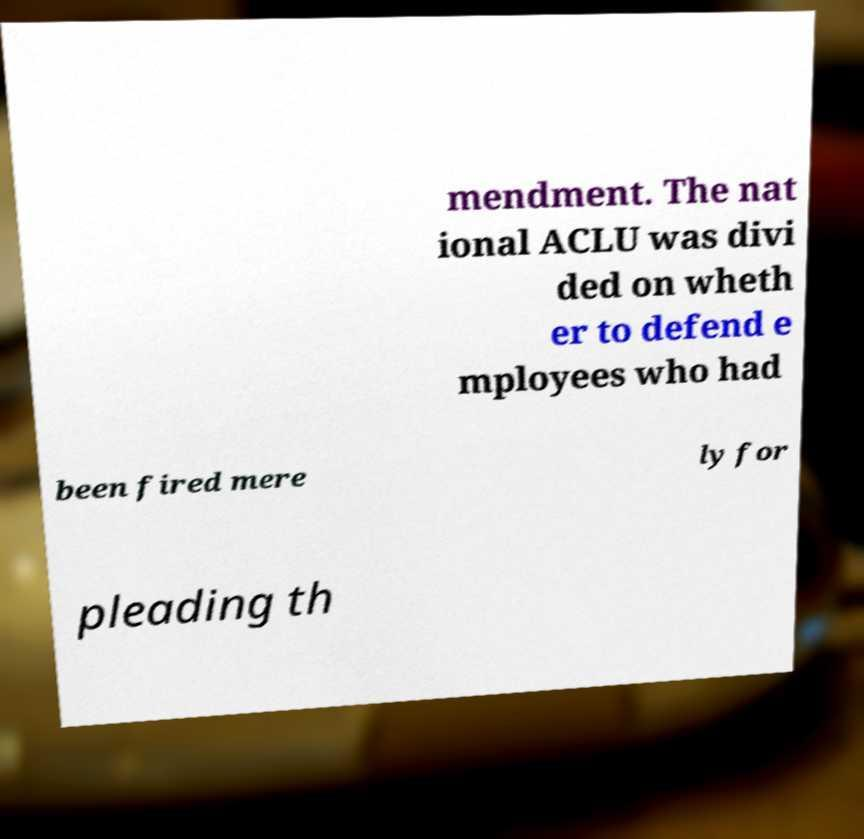Could you assist in decoding the text presented in this image and type it out clearly? mendment. The nat ional ACLU was divi ded on wheth er to defend e mployees who had been fired mere ly for pleading th 